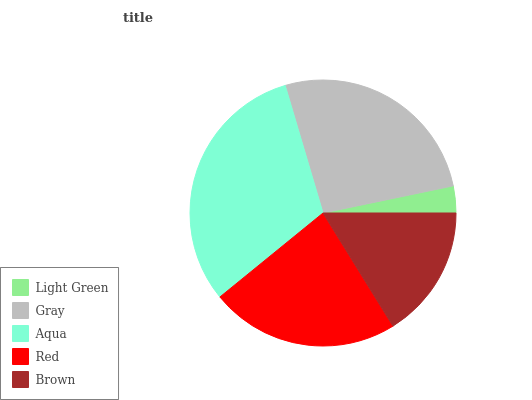Is Light Green the minimum?
Answer yes or no. Yes. Is Aqua the maximum?
Answer yes or no. Yes. Is Gray the minimum?
Answer yes or no. No. Is Gray the maximum?
Answer yes or no. No. Is Gray greater than Light Green?
Answer yes or no. Yes. Is Light Green less than Gray?
Answer yes or no. Yes. Is Light Green greater than Gray?
Answer yes or no. No. Is Gray less than Light Green?
Answer yes or no. No. Is Red the high median?
Answer yes or no. Yes. Is Red the low median?
Answer yes or no. Yes. Is Brown the high median?
Answer yes or no. No. Is Aqua the low median?
Answer yes or no. No. 